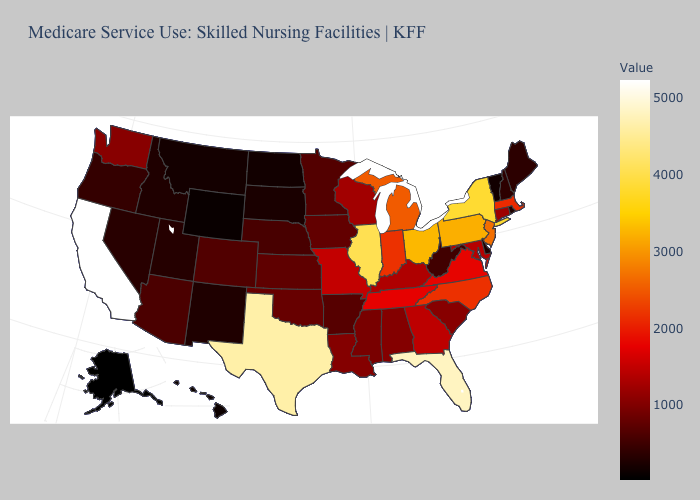Does California have a higher value than Connecticut?
Quick response, please. Yes. Does New Jersey have the lowest value in the Northeast?
Concise answer only. No. Does Delaware have the lowest value in the South?
Concise answer only. Yes. Among the states that border Virginia , does Tennessee have the highest value?
Short answer required. No. 